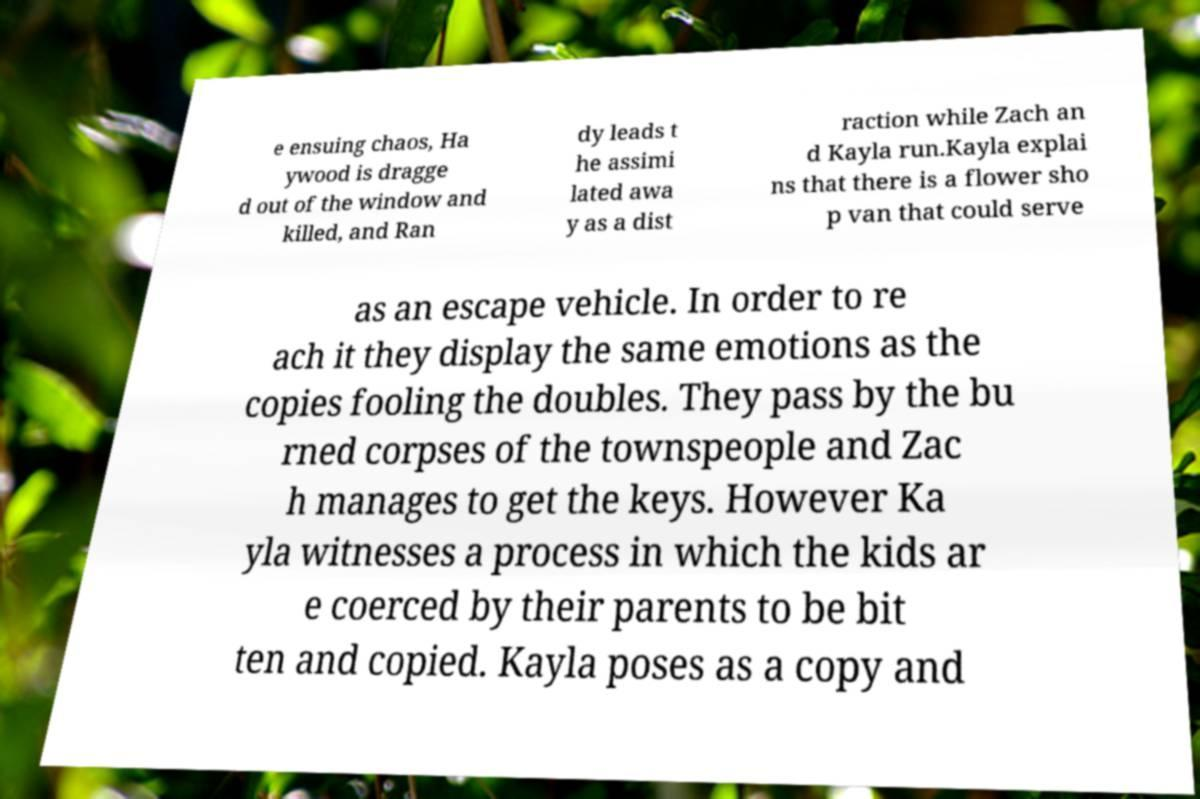Can you accurately transcribe the text from the provided image for me? e ensuing chaos, Ha ywood is dragge d out of the window and killed, and Ran dy leads t he assimi lated awa y as a dist raction while Zach an d Kayla run.Kayla explai ns that there is a flower sho p van that could serve as an escape vehicle. In order to re ach it they display the same emotions as the copies fooling the doubles. They pass by the bu rned corpses of the townspeople and Zac h manages to get the keys. However Ka yla witnesses a process in which the kids ar e coerced by their parents to be bit ten and copied. Kayla poses as a copy and 